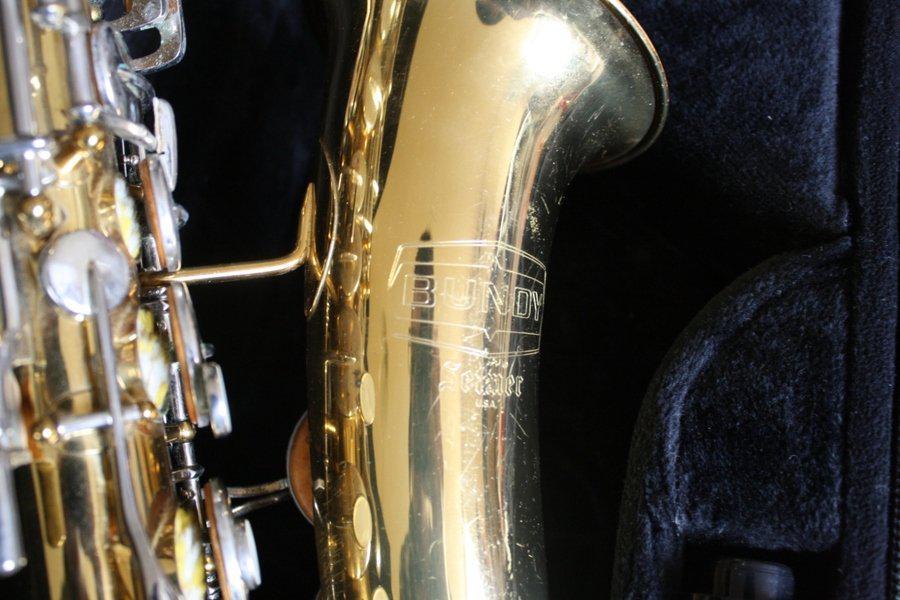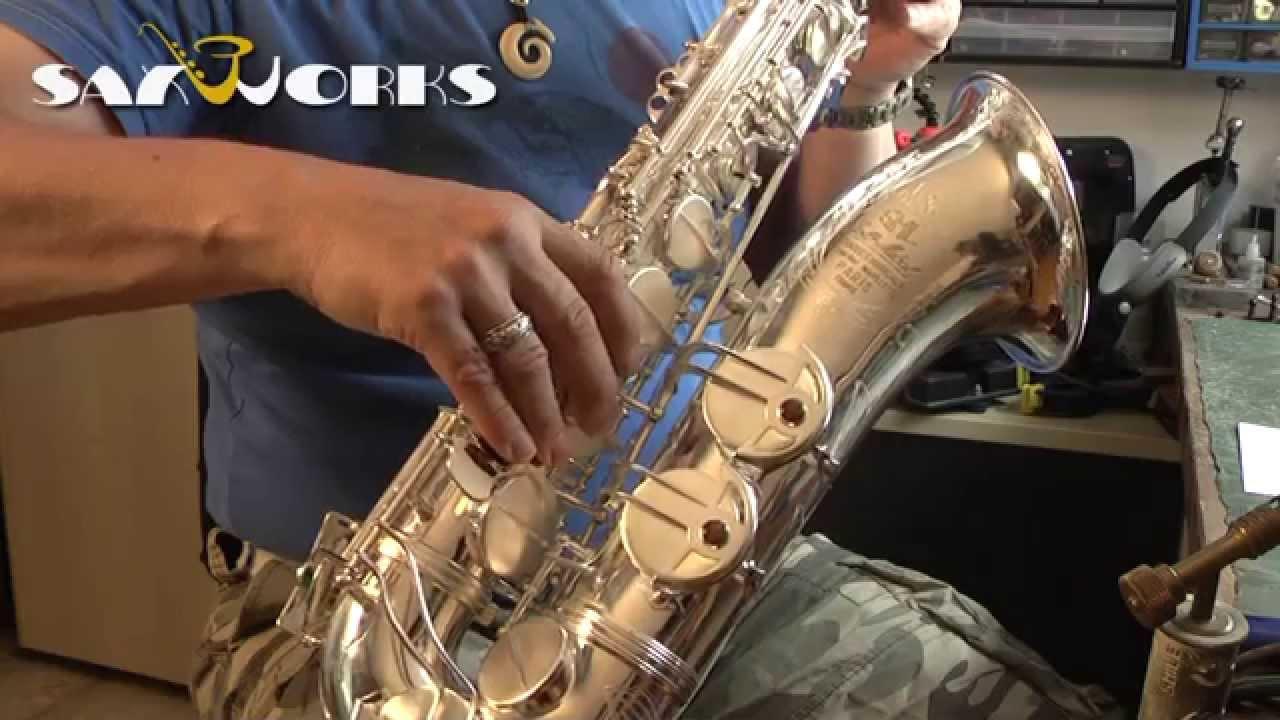The first image is the image on the left, the second image is the image on the right. Examine the images to the left and right. Is the description "One of the sax's is inside its case." accurate? Answer yes or no. Yes. The first image is the image on the left, the second image is the image on the right. Considering the images on both sides, is "The right image shows a dark saxophone with gold buttons displayed diagonally, with its mouthpiece at the upper left and its bell upturned." valid? Answer yes or no. No. 